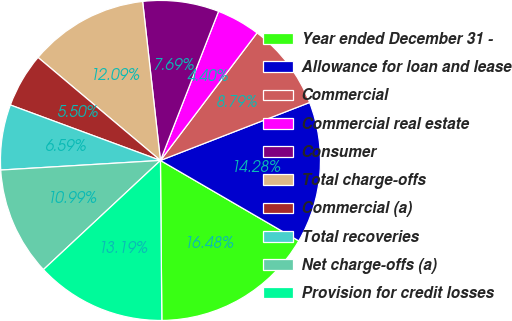Convert chart. <chart><loc_0><loc_0><loc_500><loc_500><pie_chart><fcel>Year ended December 31 -<fcel>Allowance for loan and lease<fcel>Commercial<fcel>Commercial real estate<fcel>Consumer<fcel>Total charge-offs<fcel>Commercial (a)<fcel>Total recoveries<fcel>Net charge-offs (a)<fcel>Provision for credit losses<nl><fcel>16.48%<fcel>14.28%<fcel>8.79%<fcel>4.4%<fcel>7.69%<fcel>12.09%<fcel>5.5%<fcel>6.59%<fcel>10.99%<fcel>13.19%<nl></chart> 